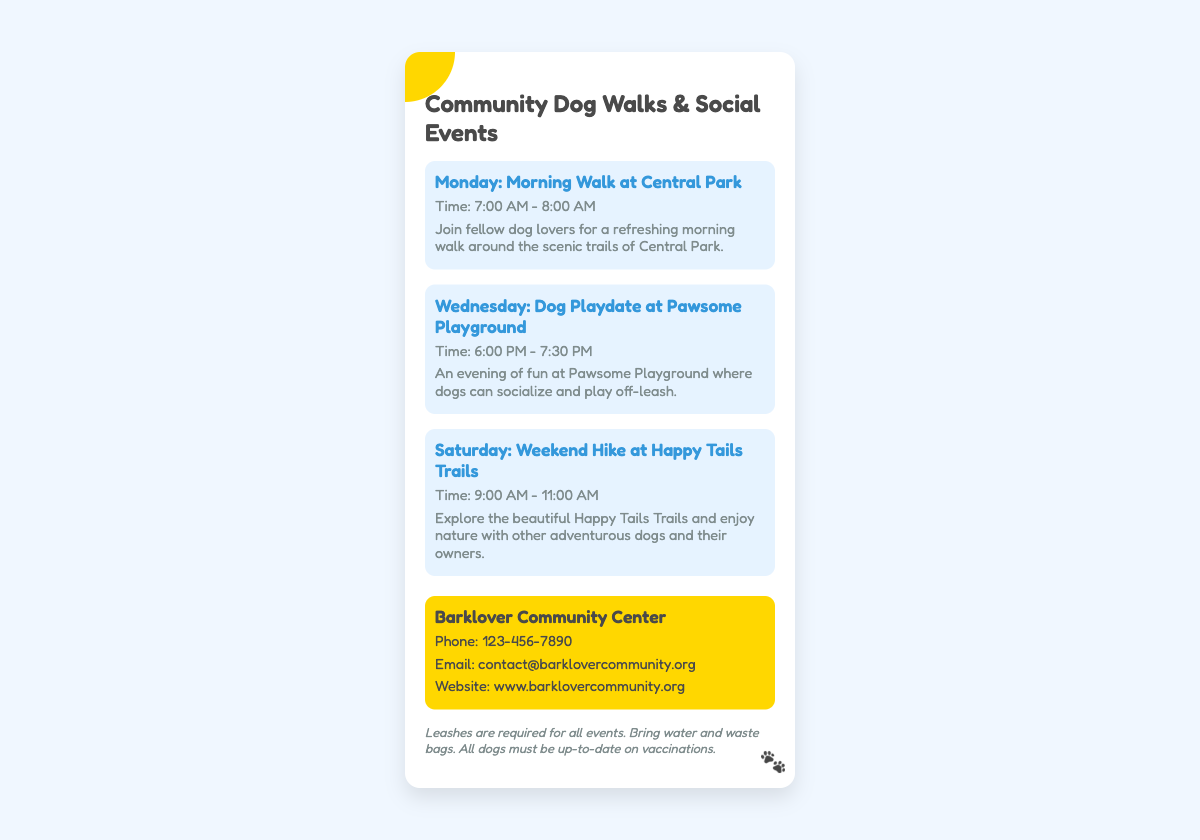What day is the morning walk scheduled? The morning walk is scheduled on Monday at Central Park.
Answer: Monday What time does the dog playdate start? The dog playdate at Pawsome Playground starts at 6:00 PM on Wednesday.
Answer: 6:00 PM Where is the weekend hike taking place? The weekend hike is taking place at Happy Tails Trails.
Answer: Happy Tails Trails What contact method is provided for inquiries? The document provides a phone number and email for inquiries, which are considered standard contact methods.
Answer: Phone and Email Which event occurs last in the week? The weekend hike occurs last in the week, on Saturday morning.
Answer: Saturday How long is the morning walk? The morning walk lasts for one hour from 7:00 AM to 8:00 AM.
Answer: One hour What is required for all events? The document states that leashes are required for all events.
Answer: Leashes What should participants bring to the events? Participants should bring water and waste bags to the events.
Answer: Water and waste bags What is the title of the document? The title mentioned in the document is "Community Dog Walks & Social Events".
Answer: Community Dog Walks & Social Events 